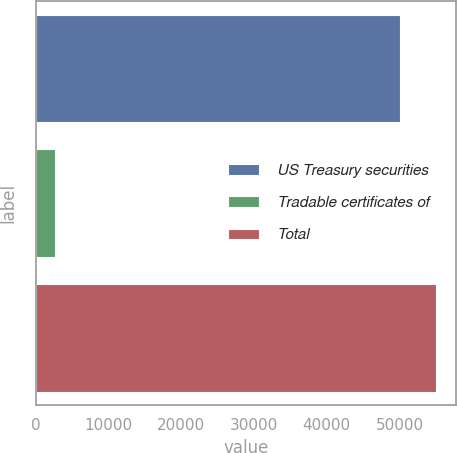Convert chart. <chart><loc_0><loc_0><loc_500><loc_500><bar_chart><fcel>US Treasury securities<fcel>Tradable certificates of<fcel>Total<nl><fcel>50056<fcel>2695<fcel>55061.6<nl></chart> 